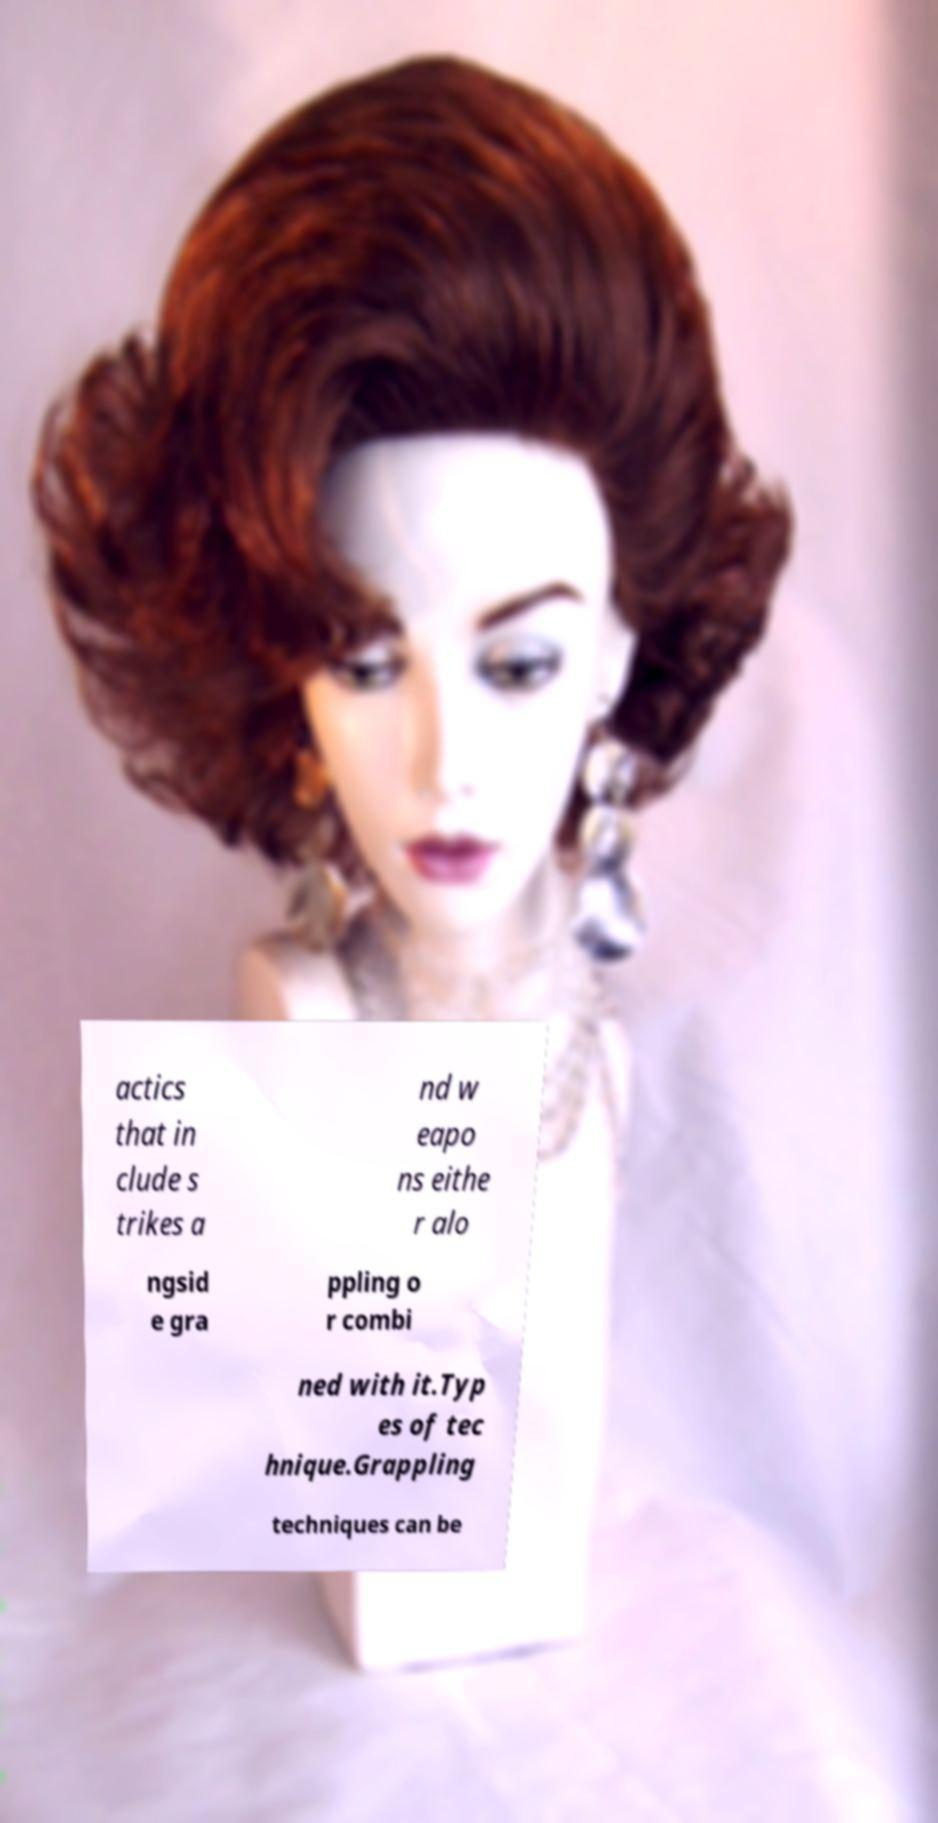Can you accurately transcribe the text from the provided image for me? actics that in clude s trikes a nd w eapo ns eithe r alo ngsid e gra ppling o r combi ned with it.Typ es of tec hnique.Grappling techniques can be 